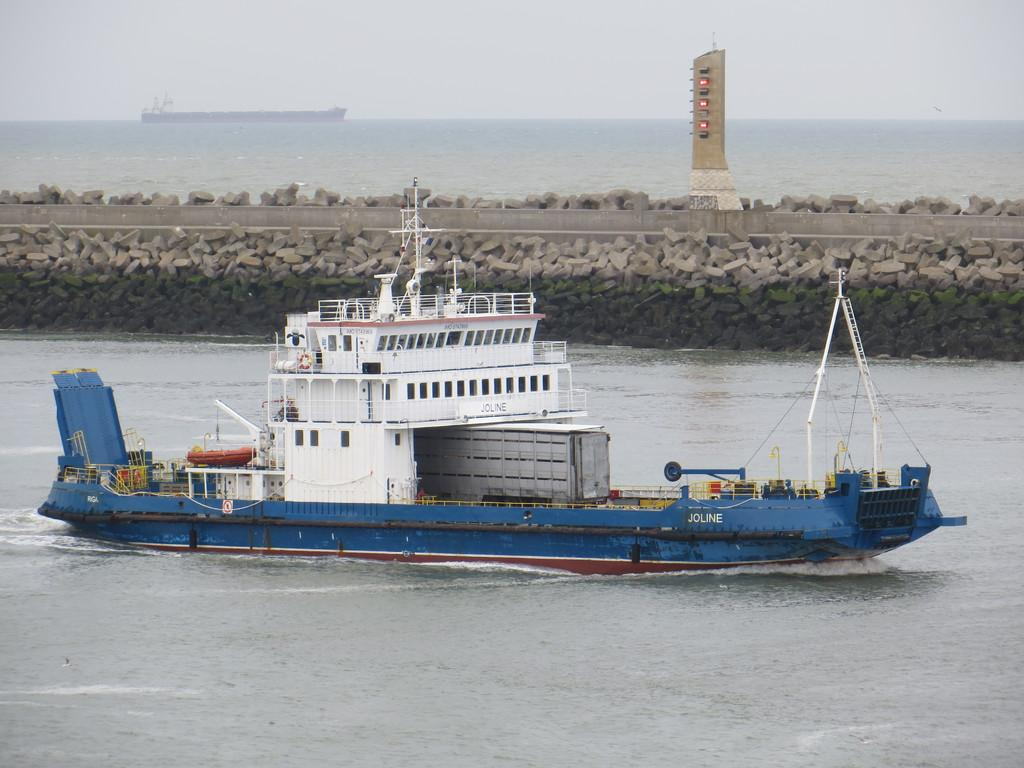What is the main subject of the image? There is a ship in the water. What can be seen in the background of the image? There is a rock wall and a tower in the background. What is visible in the sky in the image? The sky is visible in the background of the image. What type of parcel is being delivered to the ship in the image? There is no parcel visible in the image, and no indication of a delivery being made. 